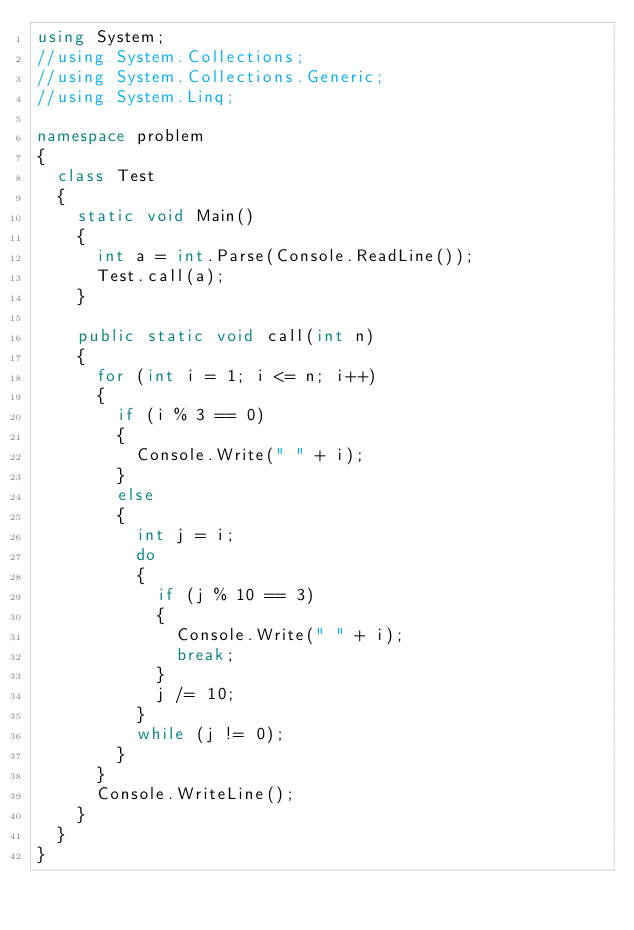Convert code to text. <code><loc_0><loc_0><loc_500><loc_500><_C#_>using System;
//using System.Collections;
//using System.Collections.Generic;
//using System.Linq;

namespace problem
{
  class Test
  {
    static void Main()
    {
      int a = int.Parse(Console.ReadLine());
      Test.call(a);
    }

    public static void call(int n)
    {
      for (int i = 1; i <= n; i++)
      {
        if (i % 3 == 0)
        {
          Console.Write(" " + i);
        }
        else
        {
          int j = i;
          do
          {
            if (j % 10 == 3)
            {
              Console.Write(" " + i);
              break;
            }
            j /= 10;
          }
          while (j != 0);
        }
      }
      Console.WriteLine();
    }
  }
}
</code> 